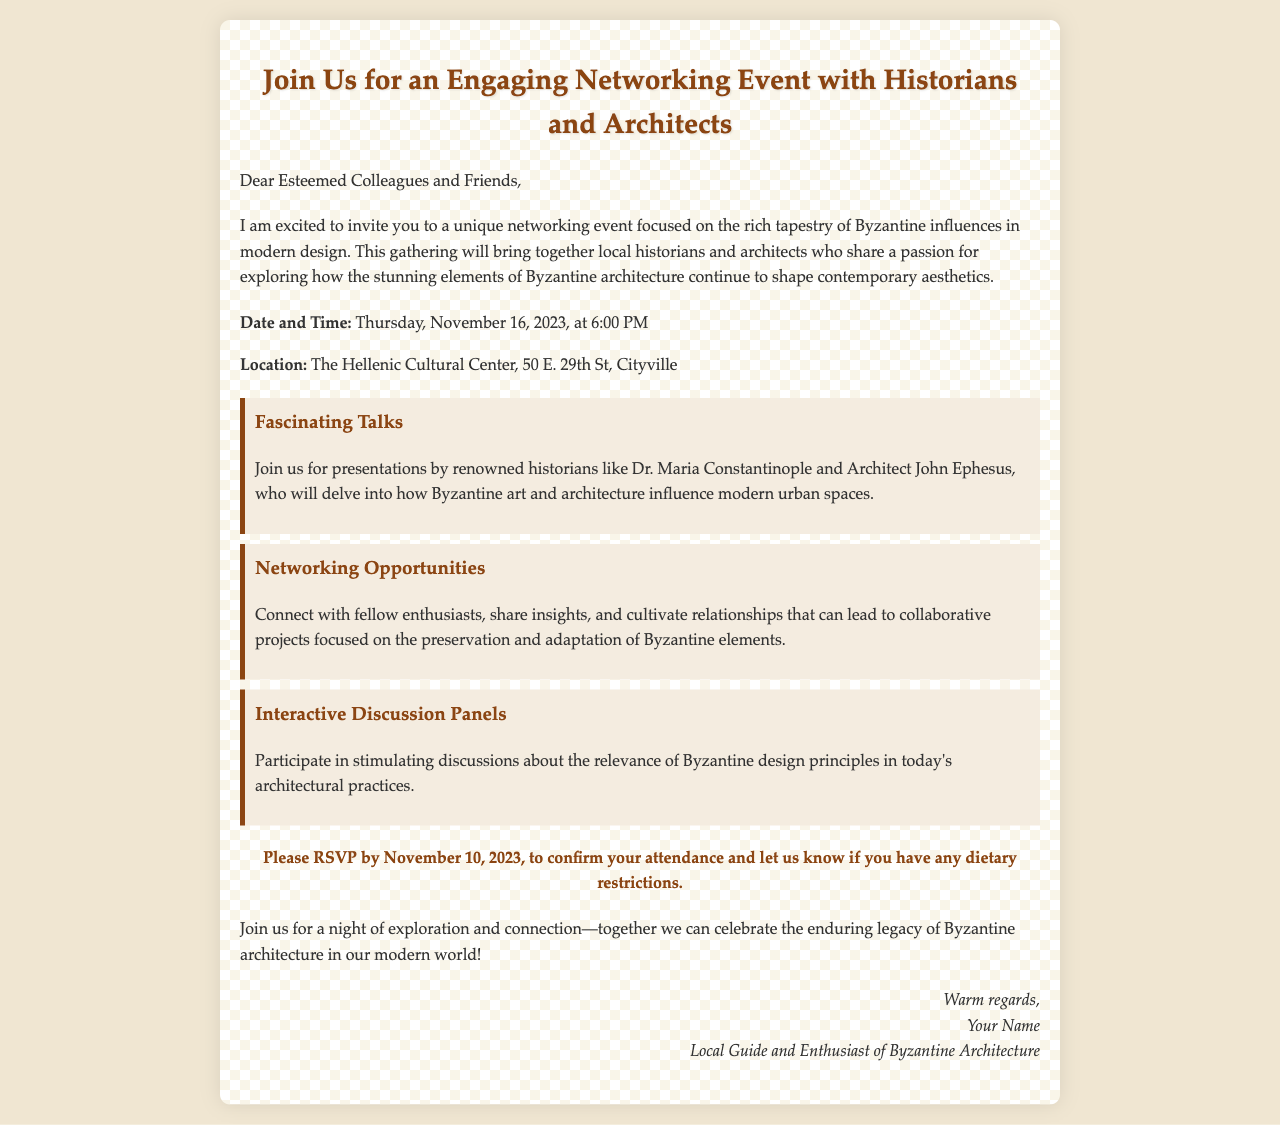What is the date of the event? The date of the event is provided in the document as Thursday, November 16, 2023.
Answer: November 16, 2023 Where is the event taking place? The location of the event is mentioned in the details section of the document.
Answer: The Hellenic Cultural Center Who are the speakers at the event? The document highlights the renowned historians and architects speaking at the event.
Answer: Dr. Maria Constantinople and Architect John Ephesus What should attendees do by November 10, 2023? The document requests attendees to respond by a specific date for attendance confirmation.
Answer: RSVP What is the theme of the networking event? The theme is outlined in the introduction section of the document, focusing on influences in design.
Answer: Byzantine influences in modern design What type of opportunities will be available at the event? The highlights describe various activities participants can engage in during the event.
Answer: Networking Opportunities How will the event contribute to professionals in the field? Reasoning from the document suggests the event aims at connecting and fostering collaborations among attendees.
Answer: Cultivate relationships What kind of discussions will take place? The document mentions interactive panels focusing on a specific architectural principle.
Answer: Relevance of Byzantine design principles 